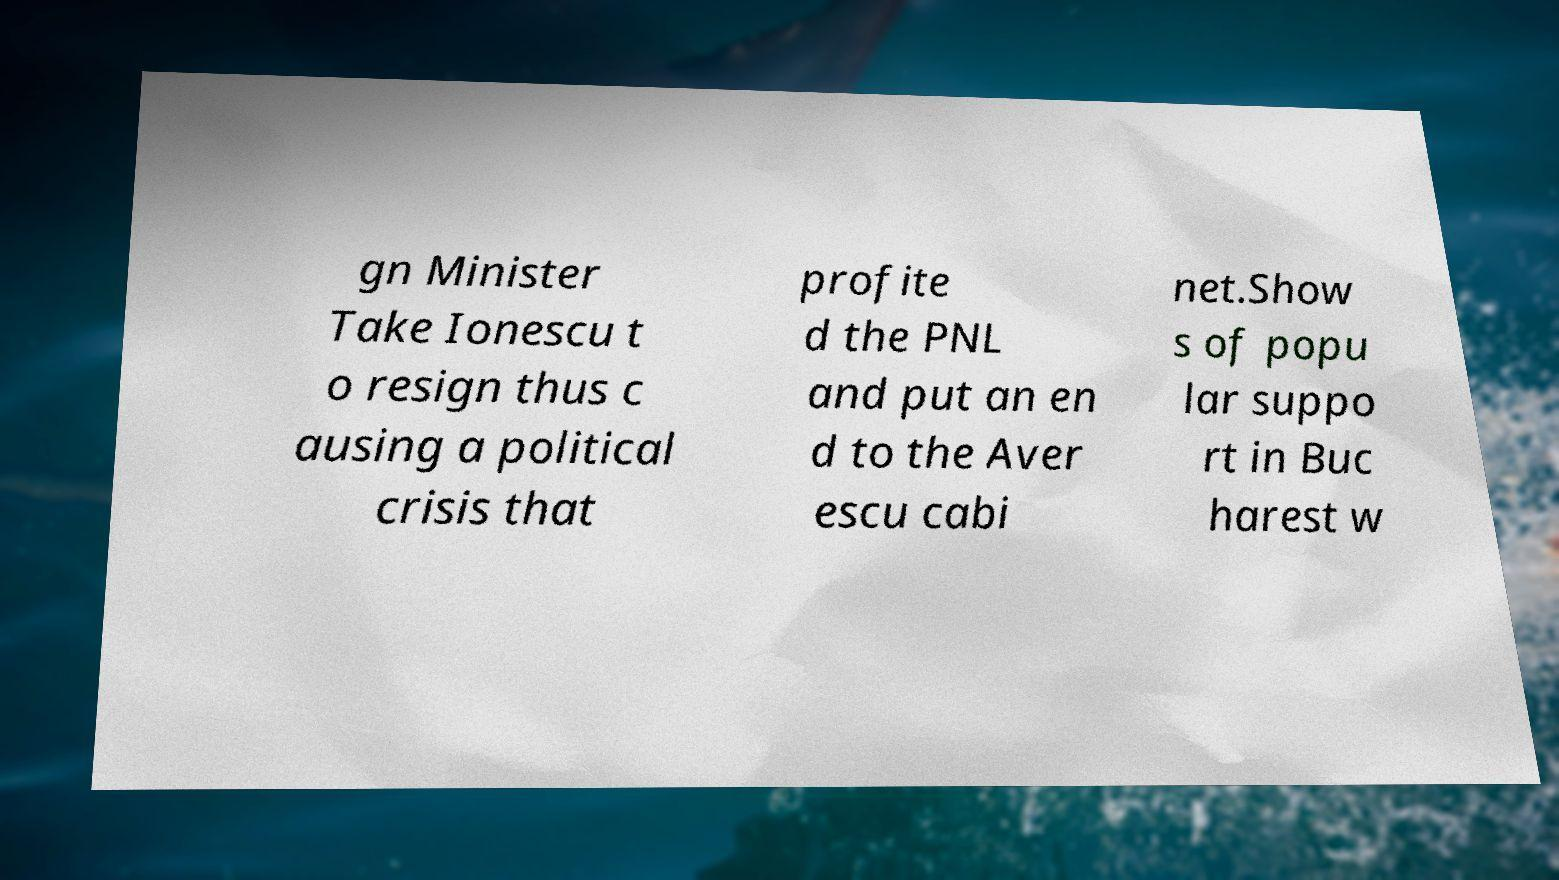Can you accurately transcribe the text from the provided image for me? gn Minister Take Ionescu t o resign thus c ausing a political crisis that profite d the PNL and put an en d to the Aver escu cabi net.Show s of popu lar suppo rt in Buc harest w 